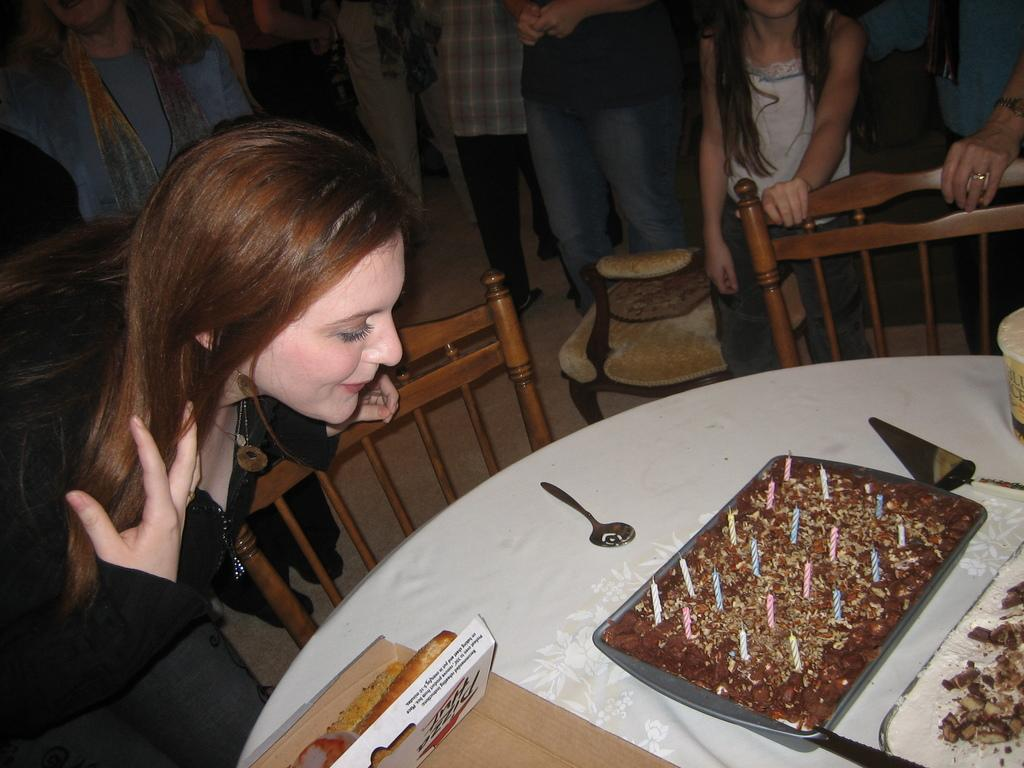Who is the main subject in the image? There is a lady in the image. What can be seen in the background of the image? There are people standing in the background of the image. What is on the table in the image? There is a cake, a spoon, and a box on the table. Is the lady driving a car in the image? No, there is no car or driving activity depicted in the image. What type of drink is being served in the image? There is no drink present in the image; it features a cake, a spoon, and a box on the table. 